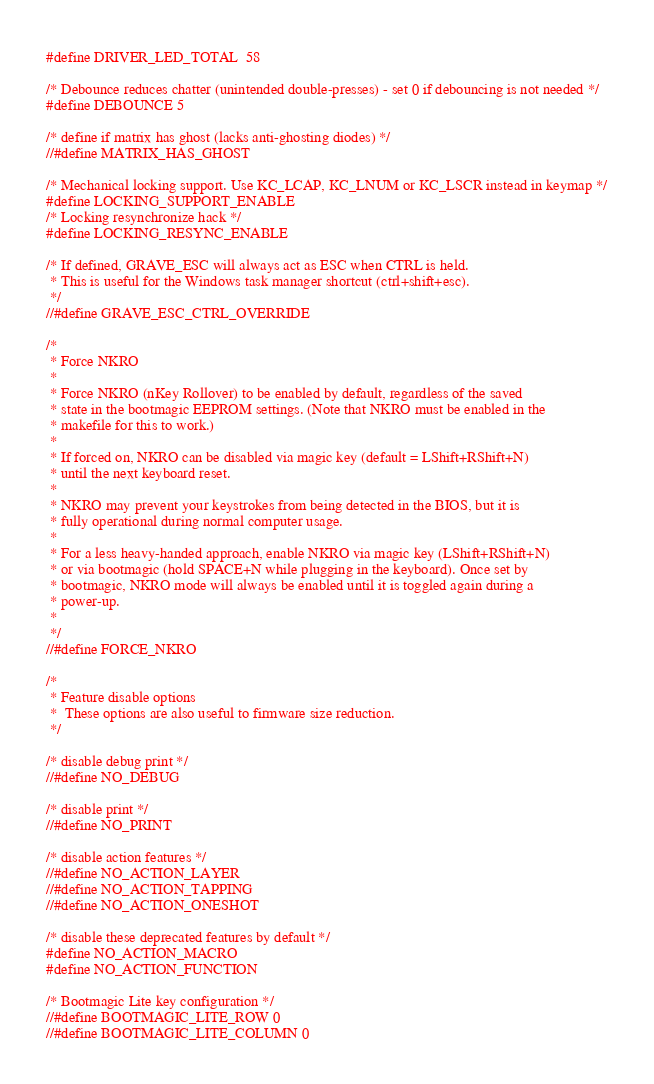Convert code to text. <code><loc_0><loc_0><loc_500><loc_500><_C_>
#define DRIVER_LED_TOTAL  58

/* Debounce reduces chatter (unintended double-presses) - set 0 if debouncing is not needed */
#define DEBOUNCE 5

/* define if matrix has ghost (lacks anti-ghosting diodes) */
//#define MATRIX_HAS_GHOST

/* Mechanical locking support. Use KC_LCAP, KC_LNUM or KC_LSCR instead in keymap */
#define LOCKING_SUPPORT_ENABLE
/* Locking resynchronize hack */
#define LOCKING_RESYNC_ENABLE

/* If defined, GRAVE_ESC will always act as ESC when CTRL is held.
 * This is useful for the Windows task manager shortcut (ctrl+shift+esc).
 */
//#define GRAVE_ESC_CTRL_OVERRIDE

/*
 * Force NKRO
 *
 * Force NKRO (nKey Rollover) to be enabled by default, regardless of the saved
 * state in the bootmagic EEPROM settings. (Note that NKRO must be enabled in the
 * makefile for this to work.)
 *
 * If forced on, NKRO can be disabled via magic key (default = LShift+RShift+N)
 * until the next keyboard reset.
 *
 * NKRO may prevent your keystrokes from being detected in the BIOS, but it is
 * fully operational during normal computer usage.
 *
 * For a less heavy-handed approach, enable NKRO via magic key (LShift+RShift+N)
 * or via bootmagic (hold SPACE+N while plugging in the keyboard). Once set by
 * bootmagic, NKRO mode will always be enabled until it is toggled again during a
 * power-up.
 *
 */
//#define FORCE_NKRO

/*
 * Feature disable options
 *  These options are also useful to firmware size reduction.
 */

/* disable debug print */
//#define NO_DEBUG

/* disable print */
//#define NO_PRINT

/* disable action features */
//#define NO_ACTION_LAYER
//#define NO_ACTION_TAPPING
//#define NO_ACTION_ONESHOT

/* disable these deprecated features by default */
#define NO_ACTION_MACRO
#define NO_ACTION_FUNCTION

/* Bootmagic Lite key configuration */
//#define BOOTMAGIC_LITE_ROW 0
//#define BOOTMAGIC_LITE_COLUMN 0
</code> 